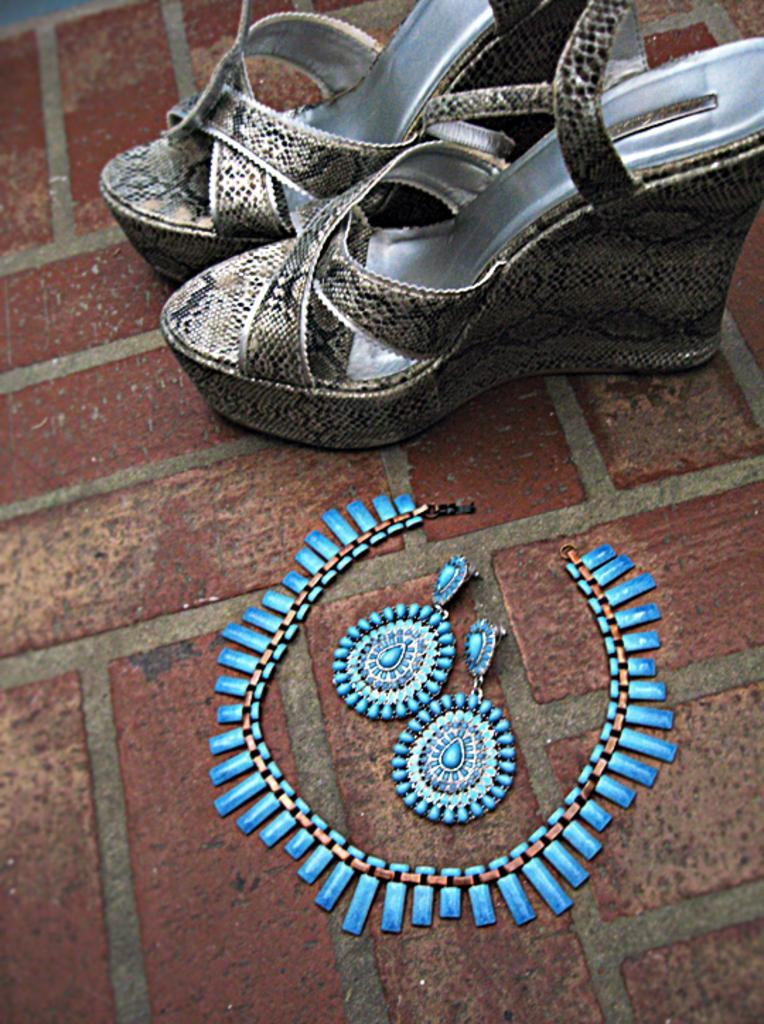What type of jewelry is present in the image? There is a necklace and earrings in the image. What color are the necklace and earrings? The necklace and earrings are blue. Where are the necklace and earrings located in the image? The necklace and earrings are placed on the floor. What type of footwear is visible in the image? There are sandals visible in the top of the image. What are the hobbies of the necklace and earrings in the image? The necklace and earrings are inanimate objects and do not have hobbies. 